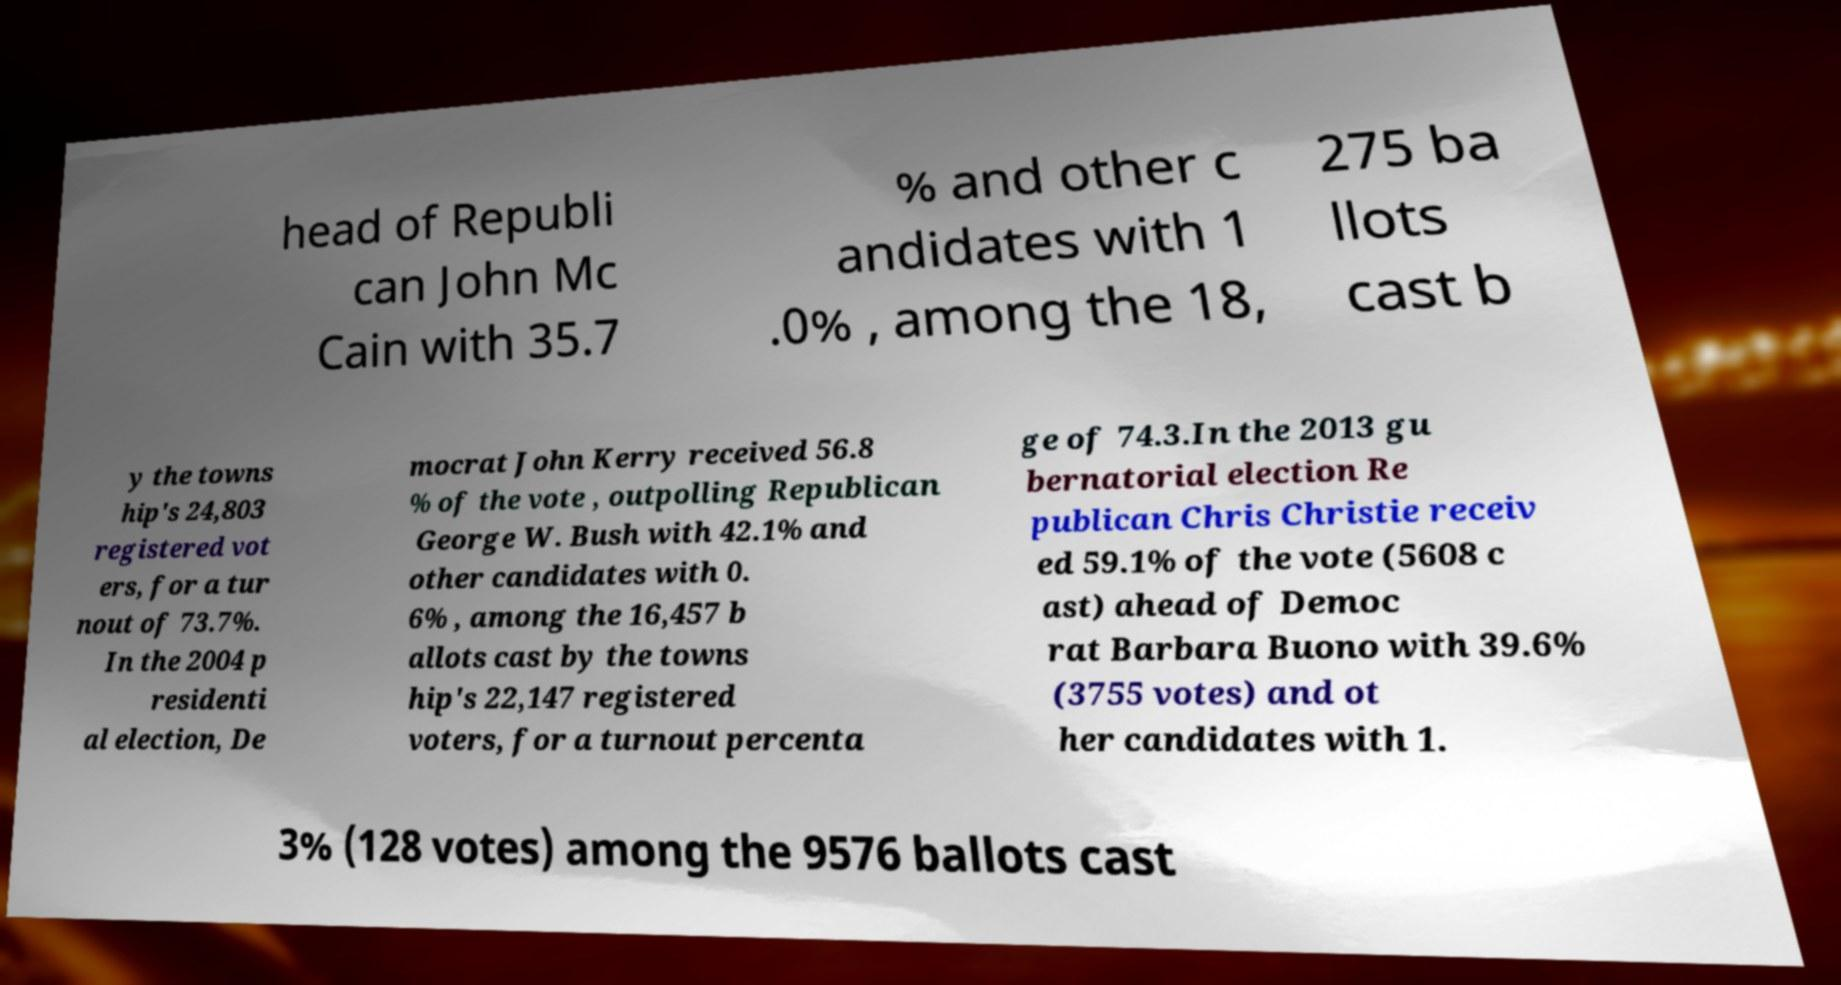Could you extract and type out the text from this image? head of Republi can John Mc Cain with 35.7 % and other c andidates with 1 .0% , among the 18, 275 ba llots cast b y the towns hip's 24,803 registered vot ers, for a tur nout of 73.7%. In the 2004 p residenti al election, De mocrat John Kerry received 56.8 % of the vote , outpolling Republican George W. Bush with 42.1% and other candidates with 0. 6% , among the 16,457 b allots cast by the towns hip's 22,147 registered voters, for a turnout percenta ge of 74.3.In the 2013 gu bernatorial election Re publican Chris Christie receiv ed 59.1% of the vote (5608 c ast) ahead of Democ rat Barbara Buono with 39.6% (3755 votes) and ot her candidates with 1. 3% (128 votes) among the 9576 ballots cast 